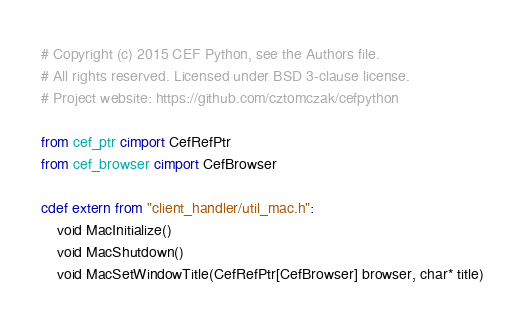Convert code to text. <code><loc_0><loc_0><loc_500><loc_500><_Cython_># Copyright (c) 2015 CEF Python, see the Authors file.
# All rights reserved. Licensed under BSD 3-clause license.
# Project website: https://github.com/cztomczak/cefpython

from cef_ptr cimport CefRefPtr
from cef_browser cimport CefBrowser

cdef extern from "client_handler/util_mac.h":
    void MacInitialize()
    void MacShutdown()
    void MacSetWindowTitle(CefRefPtr[CefBrowser] browser, char* title)
</code> 